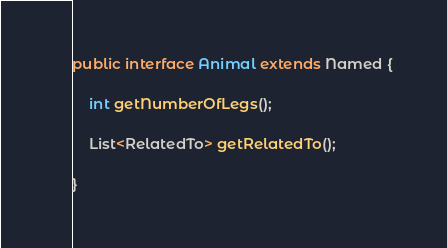<code> <loc_0><loc_0><loc_500><loc_500><_Java_>public interface Animal extends Named {

    int getNumberOfLegs();

    List<RelatedTo> getRelatedTo();

}


</code> 